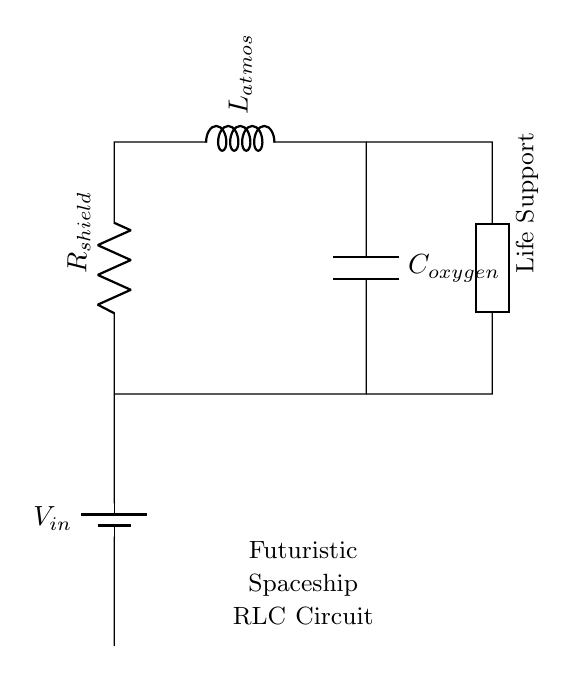What is the voltage source in this circuit? The voltage source is represented at the top left of the circuit diagram and is labeled as V_in.
Answer: V_in What components are connected in series in this circuit? The components R_shield, L_atmos, and C_oxygen are all connected in series, meaning the current flows through them sequentially without branching.
Answer: R_shield, L_atmos, C_oxygen What is the purpose of the inductor in the life support system? The inductor, labeled L_atmos, is typically used to store energy in a magnetic field when current flows through it, which helps stabilize the current in the circuit.
Answer: Energy storage What type of circuit configuration does this RLC circuit represent? This RLC circuit is a series connection since the components are aligned in a single pathway for current flow.
Answer: Series Why might a capacitor be important in a life support system? The capacitor, labeled C_oxygen, plays a crucial role by storing charge and smoothing voltage fluctuations, which helps maintain a stable power supply for critical systems like life support.
Answer: Stabilizes voltage What happens to the impedance as frequency increases in this RLC circuit? In a series RLC circuit, as frequency increases, the inductive reactance increases while the capacitive reactance decreases, affecting the total impedance.
Answer: Impedance changes Which component in the circuit would primarily affect the current flow? The resistor, labeled R_shield, primarily affects the current flow because it introduces resistance, controlling how much current can pass through the circuit regardless of the other components.
Answer: R_shield 